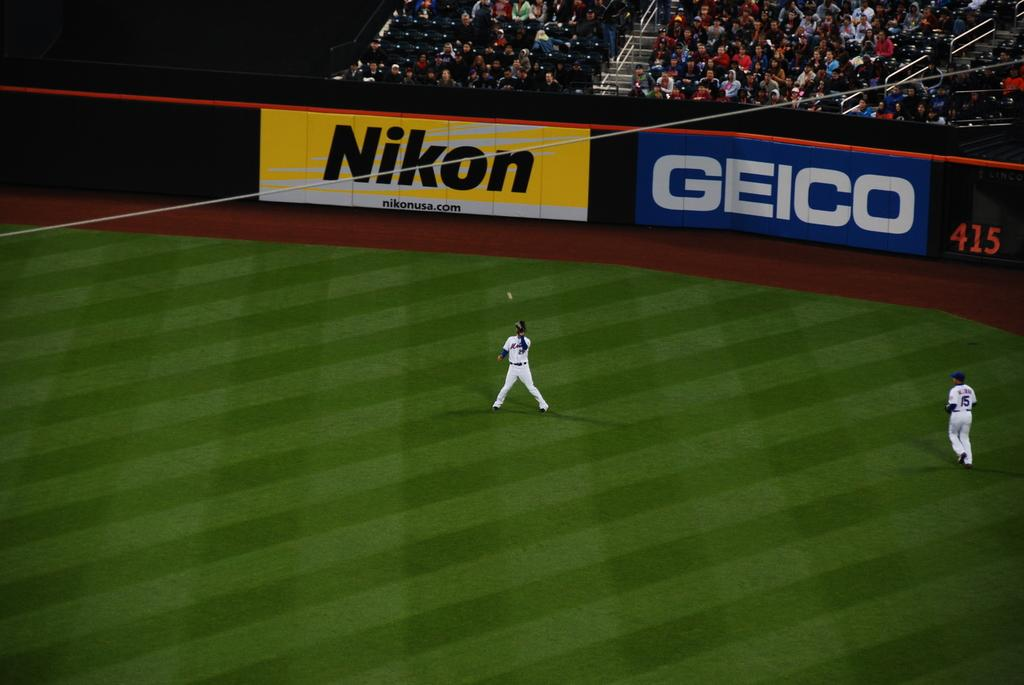Provide a one-sentence caption for the provided image. A wide shot of a baseball field with the sponsers Nikon and Geico in the background. 